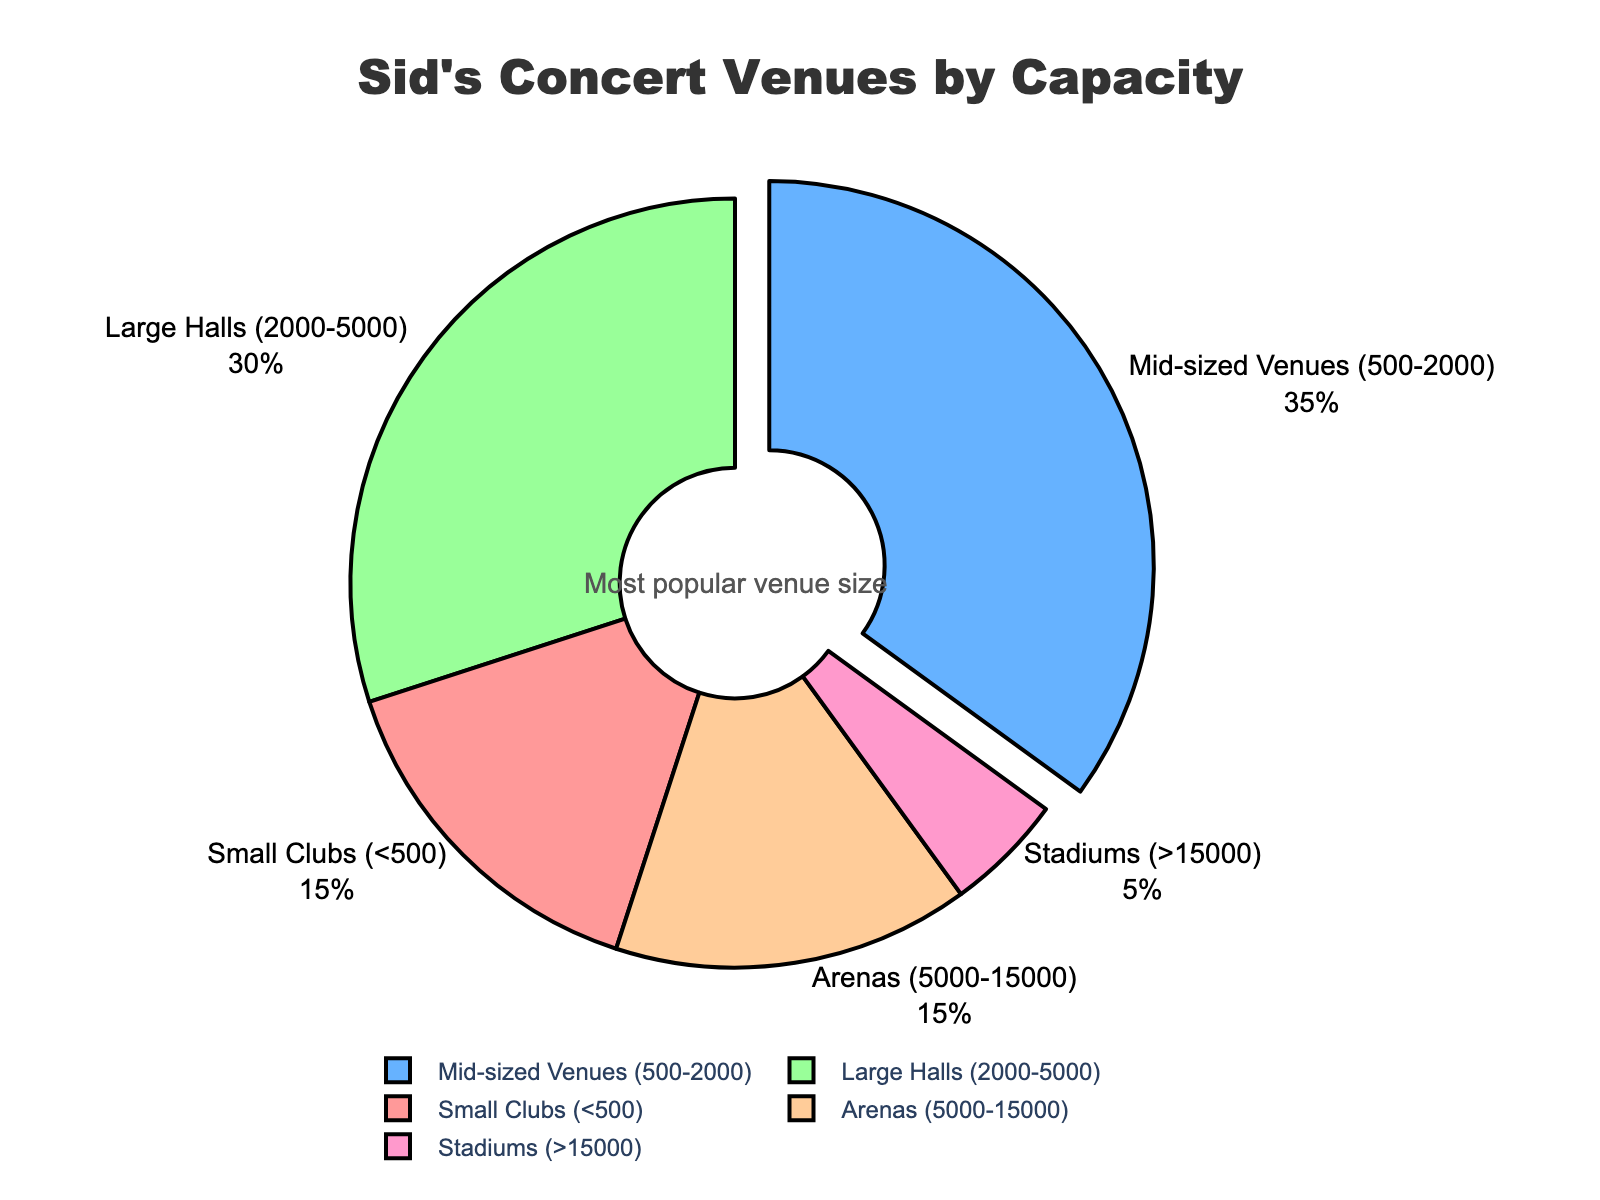What's the most common venue type for Sid's concerts? The pie chart clearly shows the proportion each venue type represents. The mid-sized venues (500-2000) have the largest percentage at 35%.
Answer: Mid-sized venues (500-2000) Which venue type has the lowest proportion of Sid's concerts? The pie chart shows the smallest slice is for Stadiums (>15000), which only accounts for 5%.
Answer: Stadiums (>15000) How does the proportion of Small Clubs compare to Arenas? Arenas and Small Clubs both occupy approximately the same portion, each being 15%.
Answer: Equal (both 15%) What is the combined percentage of concerts held at Mid-sized Venues and Large Halls? Add the percentages for Mid-sized Venues and Large Halls: 35% (Mid-sized Venues) + 30% (Large Halls) = 65%.
Answer: 65% Which venue types together compose more than half of Sid's concerts? Sum the percentages until it exceeds 50%. Mid-sized Venues (35%) + Large Halls (30%) = 65%, which is greater than half the total.
Answer: Mid-sized Venues and Large Halls What venue capacity is most pulled out in the pie chart? The pie chart annotation and visual indication highlight that the Mid-sized Venues section is pulled out the most.
Answer: Mid-sized Venues (500-2000) How much larger is the proportion of Large Halls than Stadiums? Subtract the percentage of Stadiums from Large Halls: 30% (Large Halls) - 5% (Stadiums) = 25%.
Answer: 25% If Sid wants to focus on the top two most frequent venue sizes, which should he consider? The top two are Mid-sized Venues (35%) and Large Halls (30%) based on their proportions.
Answer: Mid-sized Venues and Large Halls Which color represents the Arenas in the pie chart? The arenas are represented by a distinct color in the pie chart to make them identifiable. The color shown for Arenas is light orange.
Answer: Light orange How much smaller is the proportion of Arenas compared to Mid-sized Venues? Subtract the percentage of Arenas from Mid-sized Venues: 35% (Mid-sized Venues) - 15% (Arenas) = 20% smaller.
Answer: 20% 